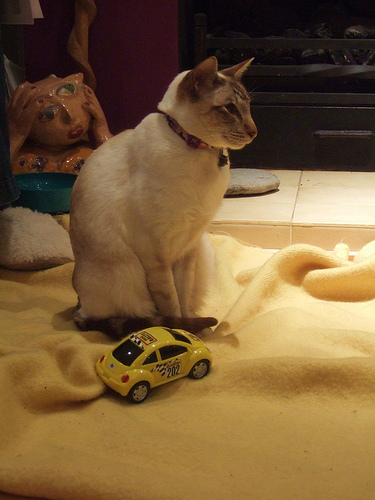What breed might the cat be given its coat and color pattern? The cat's creamy white coat with darker points on its ears, face, paws, and tail are indicative of the Siamese or a Siamese mix. These distinct features are typical of the breed. 